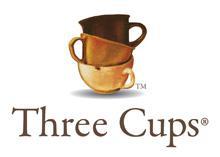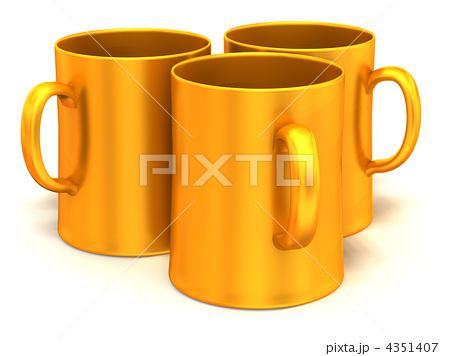The first image is the image on the left, the second image is the image on the right. For the images displayed, is the sentence "There are exactly three cups in each image in the pair." factually correct? Answer yes or no. Yes. 